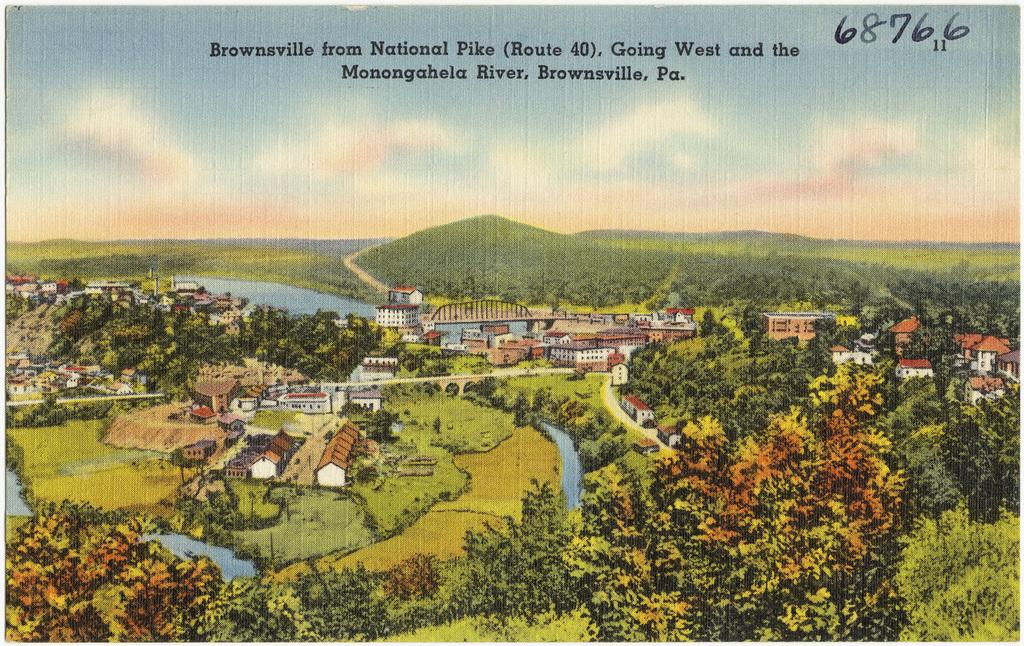<image>
Summarize the visual content of the image. a poster of a town in brownsville, PA 